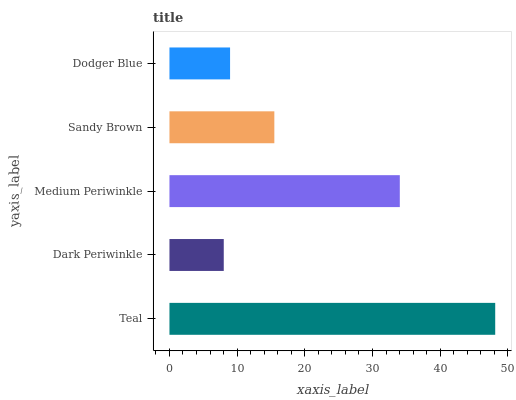Is Dark Periwinkle the minimum?
Answer yes or no. Yes. Is Teal the maximum?
Answer yes or no. Yes. Is Medium Periwinkle the minimum?
Answer yes or no. No. Is Medium Periwinkle the maximum?
Answer yes or no. No. Is Medium Periwinkle greater than Dark Periwinkle?
Answer yes or no. Yes. Is Dark Periwinkle less than Medium Periwinkle?
Answer yes or no. Yes. Is Dark Periwinkle greater than Medium Periwinkle?
Answer yes or no. No. Is Medium Periwinkle less than Dark Periwinkle?
Answer yes or no. No. Is Sandy Brown the high median?
Answer yes or no. Yes. Is Sandy Brown the low median?
Answer yes or no. Yes. Is Medium Periwinkle the high median?
Answer yes or no. No. Is Medium Periwinkle the low median?
Answer yes or no. No. 